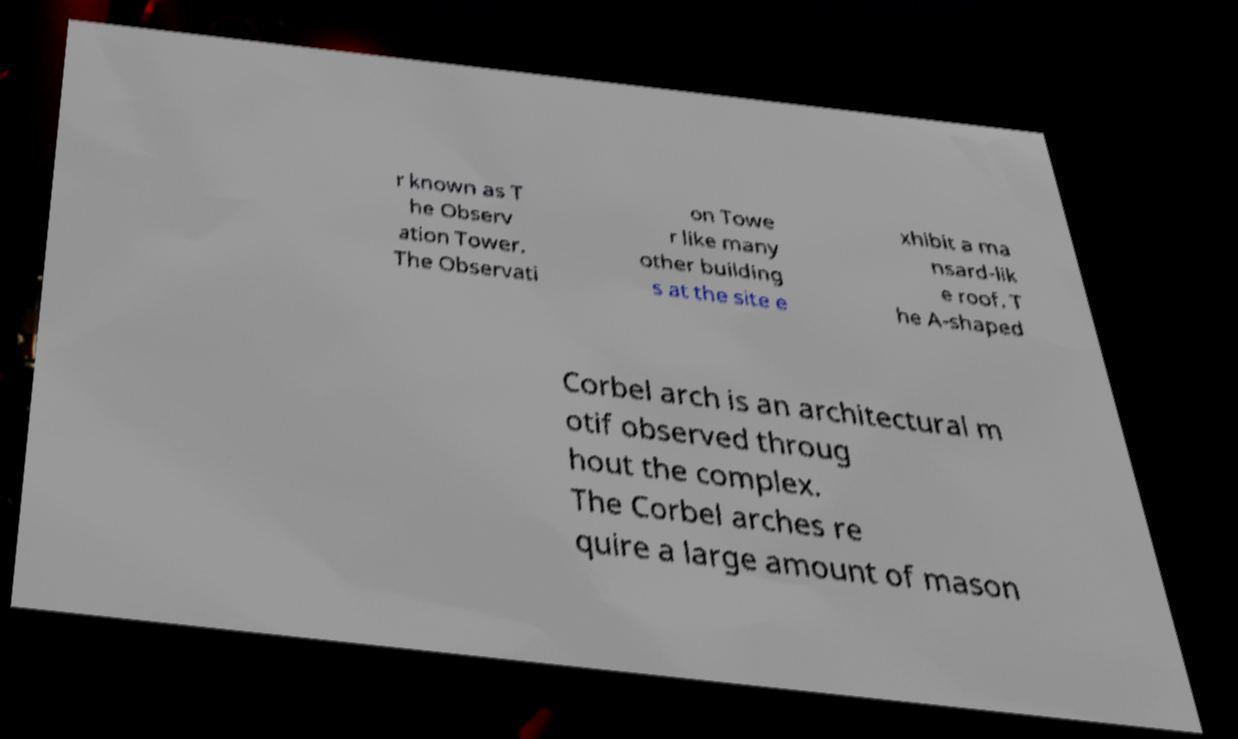Could you assist in decoding the text presented in this image and type it out clearly? r known as T he Observ ation Tower. The Observati on Towe r like many other building s at the site e xhibit a ma nsard-lik e roof. T he A-shaped Corbel arch is an architectural m otif observed throug hout the complex. The Corbel arches re quire a large amount of mason 